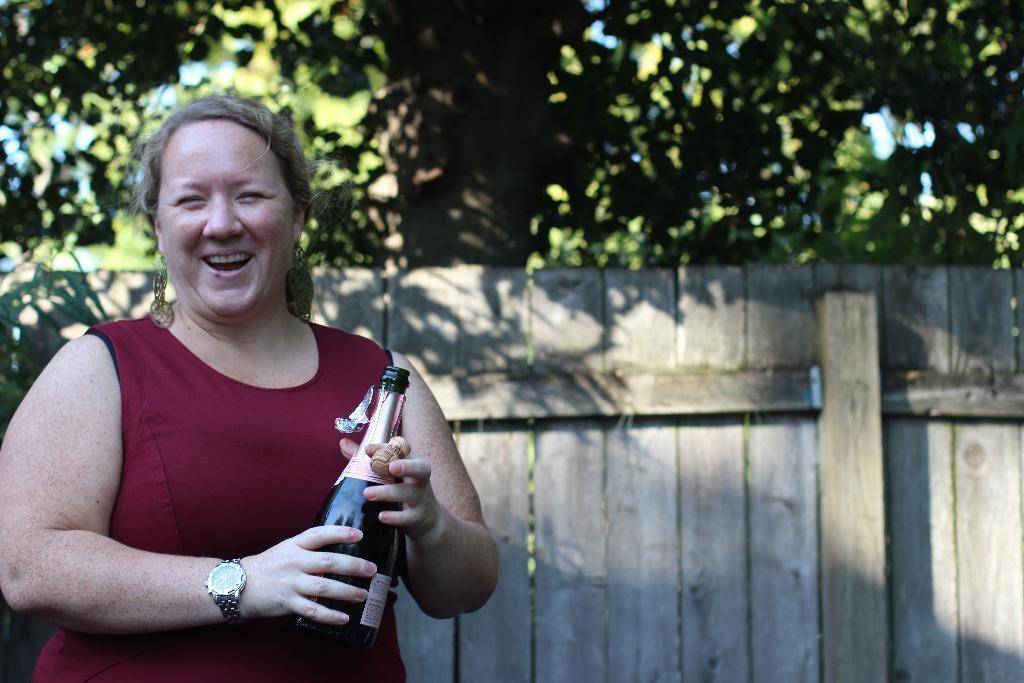Can you describe this image briefly? In this picture we can see a woman who is holding a bottle with her hands. She is smiling. On the background there are trees. 